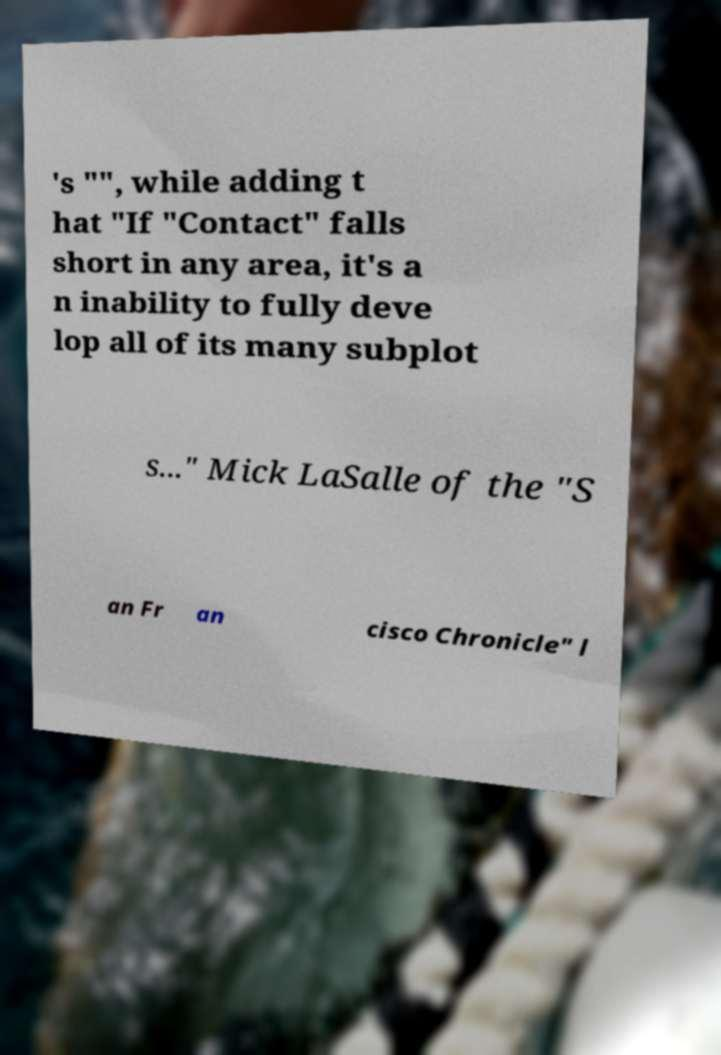Could you extract and type out the text from this image? 's "", while adding t hat "If "Contact" falls short in any area, it's a n inability to fully deve lop all of its many subplot s..." Mick LaSalle of the "S an Fr an cisco Chronicle" l 